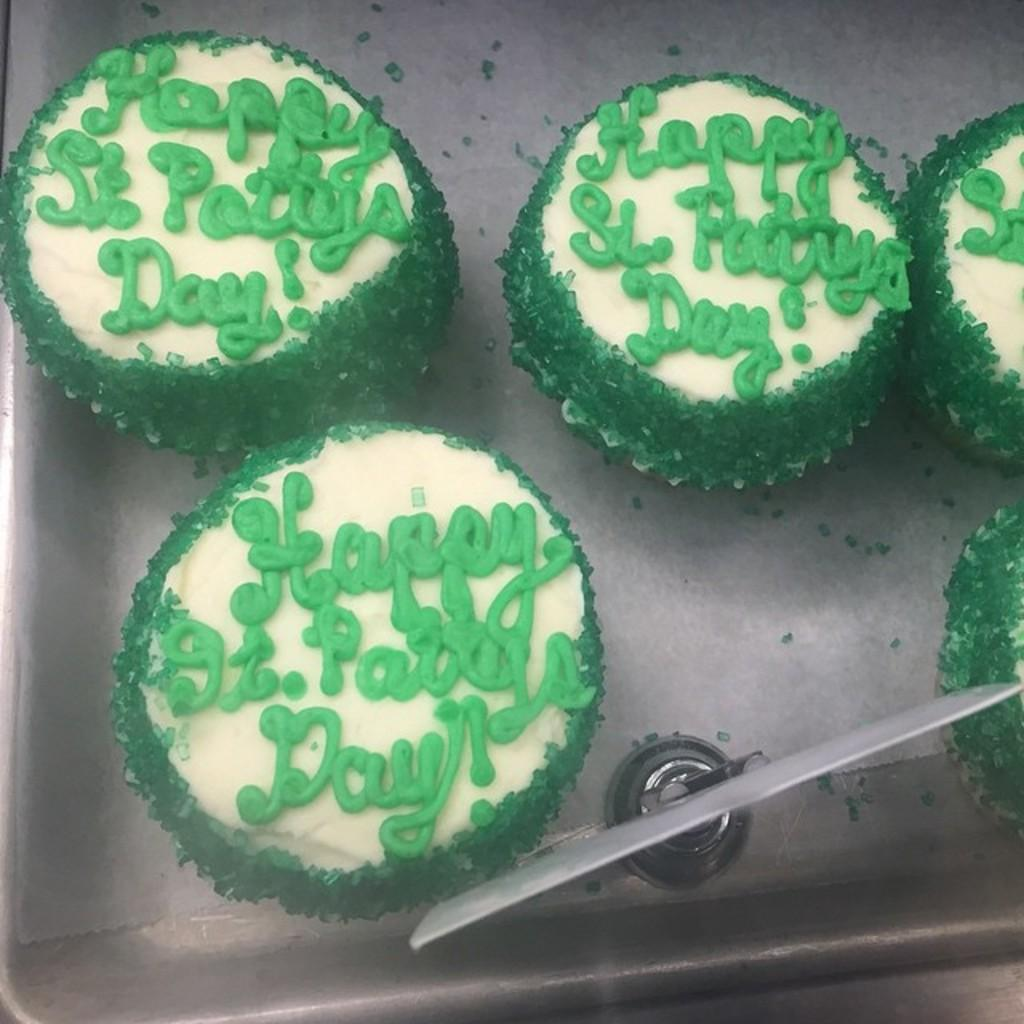What type of food can be seen in the image? There are cake pieces in the image. What color are the cake pieces? The cake pieces are green in color. How are the cake pieces arranged or contained in the image? The cake pieces are in a tray. Are there any nails sticking out of the cake pieces in the image? No, there are no nails present in the image, and the cake pieces are not depicted with any nails sticking out. 